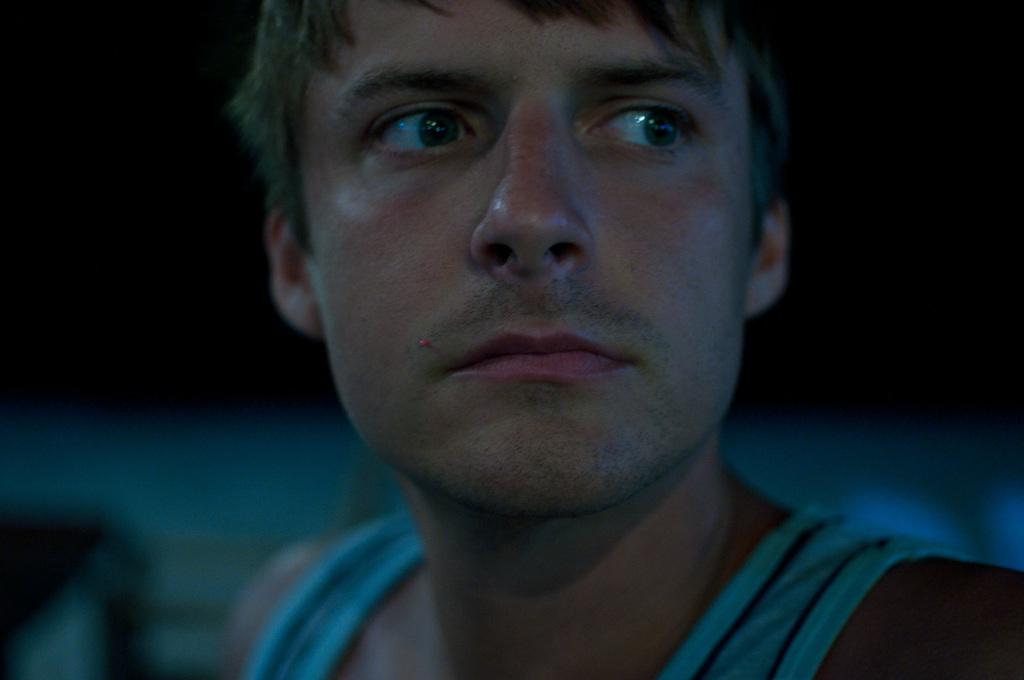What is the main subject of the image? The main subject of the image is a man. Can you describe the background of the image? The background of the image is dark and blurry. How much wealth does the chicken in the image possess? There is no chicken present in the image, so it is not possible to determine its wealth. 